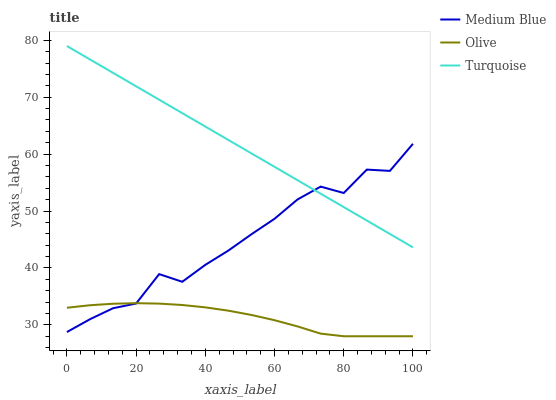Does Olive have the minimum area under the curve?
Answer yes or no. Yes. Does Turquoise have the maximum area under the curve?
Answer yes or no. Yes. Does Medium Blue have the minimum area under the curve?
Answer yes or no. No. Does Medium Blue have the maximum area under the curve?
Answer yes or no. No. Is Turquoise the smoothest?
Answer yes or no. Yes. Is Medium Blue the roughest?
Answer yes or no. Yes. Is Medium Blue the smoothest?
Answer yes or no. No. Is Turquoise the roughest?
Answer yes or no. No. Does Medium Blue have the lowest value?
Answer yes or no. No. Does Medium Blue have the highest value?
Answer yes or no. No. Is Olive less than Turquoise?
Answer yes or no. Yes. Is Turquoise greater than Olive?
Answer yes or no. Yes. Does Olive intersect Turquoise?
Answer yes or no. No. 